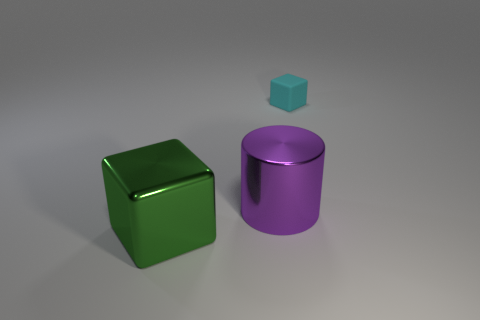Do the purple metallic thing and the cyan object have the same size?
Keep it short and to the point. No. Are there an equal number of green metallic cubes that are left of the large green metal thing and objects on the left side of the small thing?
Ensure brevity in your answer.  No. Does the cube on the left side of the tiny cyan rubber thing have the same size as the metallic object that is to the right of the big green block?
Offer a very short reply. Yes. There is a object that is on the right side of the large green shiny object and in front of the cyan matte cube; what material is it made of?
Your answer should be compact. Metal. Are there fewer big gray metal things than big cylinders?
Your response must be concise. Yes. There is a metal object that is behind the object in front of the purple shiny object; what size is it?
Keep it short and to the point. Large. The big metal thing to the right of the cube in front of the cube that is behind the large purple cylinder is what shape?
Ensure brevity in your answer.  Cylinder. What color is the object that is made of the same material as the big green cube?
Give a very brief answer. Purple. What color is the cube that is left of the block on the right side of the block that is on the left side of the cyan thing?
Your response must be concise. Green. How many cubes are either matte objects or large purple objects?
Your answer should be compact. 1. 